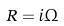<formula> <loc_0><loc_0><loc_500><loc_500>R = i \Omega</formula> 